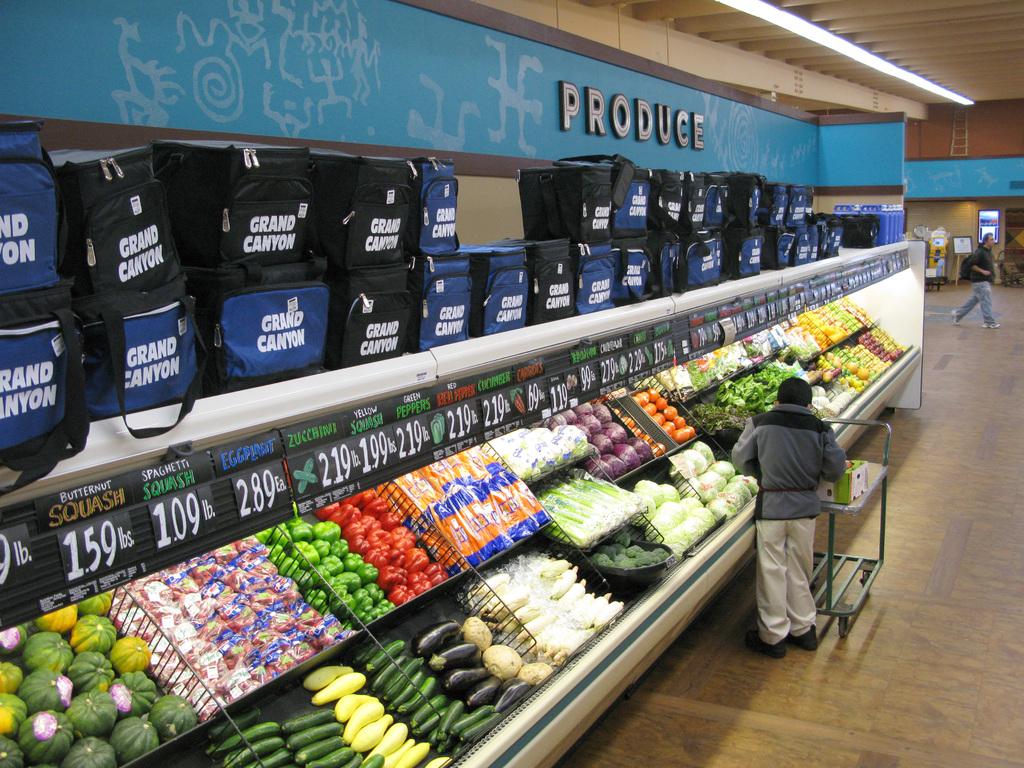What is the price of the peppers?
Keep it short and to the point. 2.19. What is the price of the squash?
Provide a succinct answer. 1.59. 